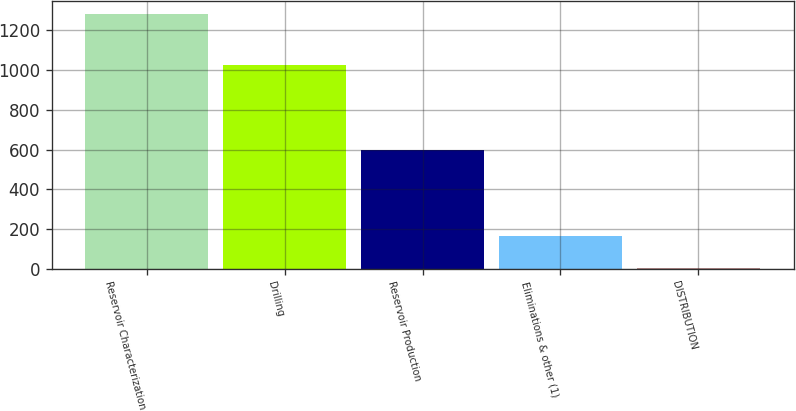<chart> <loc_0><loc_0><loc_500><loc_500><bar_chart><fcel>Reservoir Characterization<fcel>Drilling<fcel>Reservoir Production<fcel>Eliminations & other (1)<fcel>DISTRIBUTION<nl><fcel>1285<fcel>1026<fcel>598<fcel>163<fcel>6<nl></chart> 